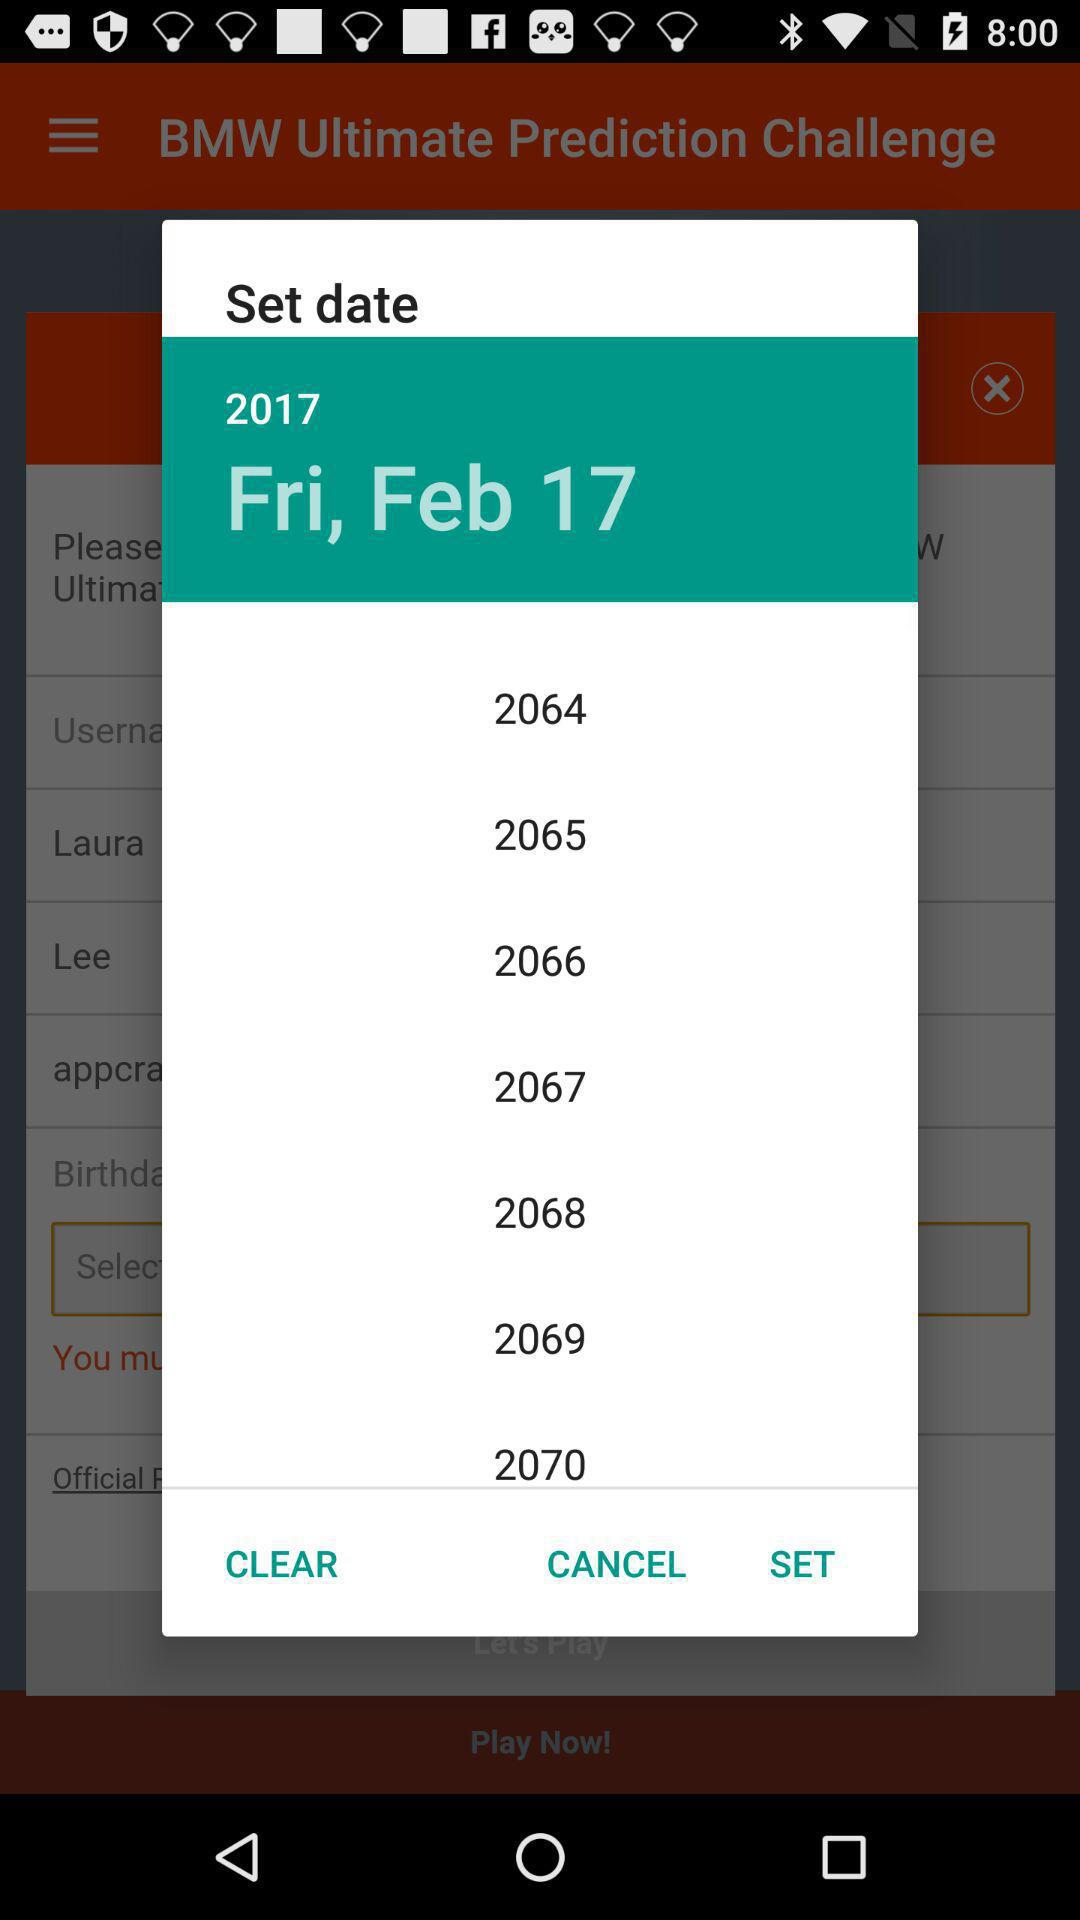What is the day of the selected date? The day is Friday. 